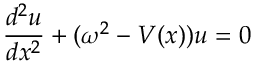<formula> <loc_0><loc_0><loc_500><loc_500>\frac { d ^ { 2 } u } { d x ^ { 2 } } + ( \omega ^ { 2 } - V ( x ) ) u = 0</formula> 